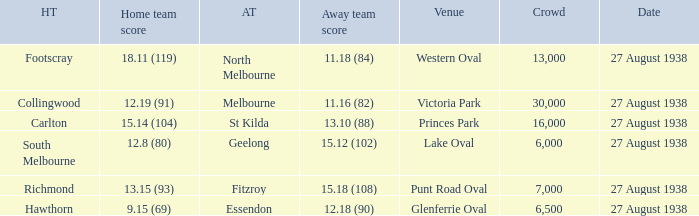Which home team had the away team score 15.18 (108) against them? 13.15 (93). 